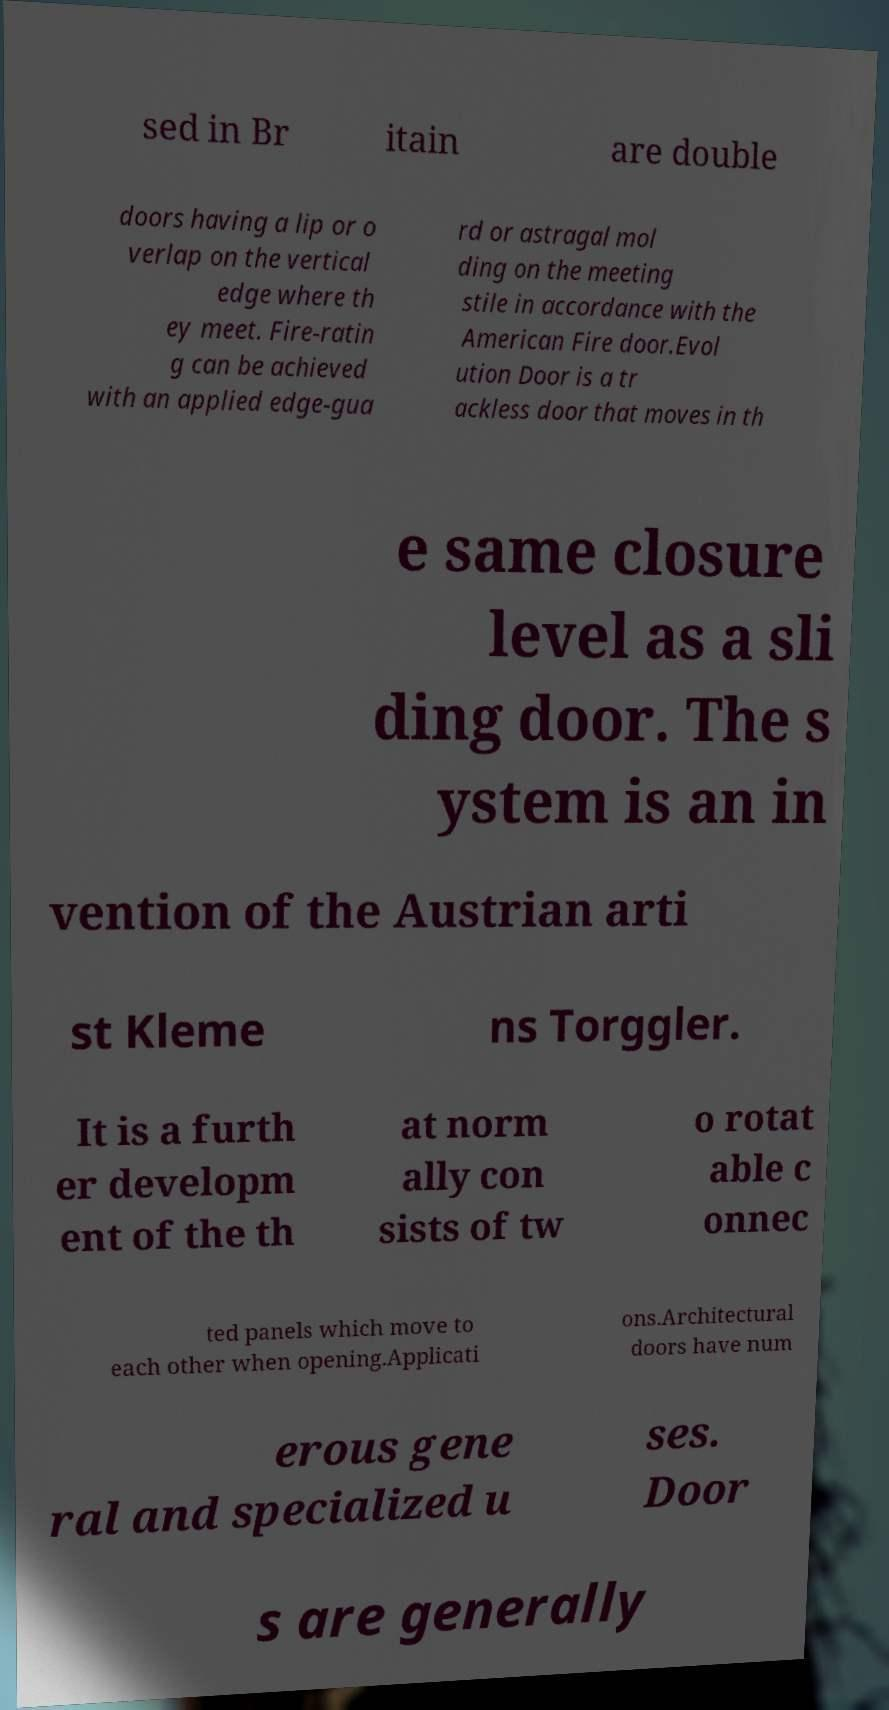Could you assist in decoding the text presented in this image and type it out clearly? sed in Br itain are double doors having a lip or o verlap on the vertical edge where th ey meet. Fire-ratin g can be achieved with an applied edge-gua rd or astragal mol ding on the meeting stile in accordance with the American Fire door.Evol ution Door is a tr ackless door that moves in th e same closure level as a sli ding door. The s ystem is an in vention of the Austrian arti st Kleme ns Torggler. It is a furth er developm ent of the th at norm ally con sists of tw o rotat able c onnec ted panels which move to each other when opening.Applicati ons.Architectural doors have num erous gene ral and specialized u ses. Door s are generally 